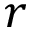Convert formula to latex. <formula><loc_0><loc_0><loc_500><loc_500>r</formula> 